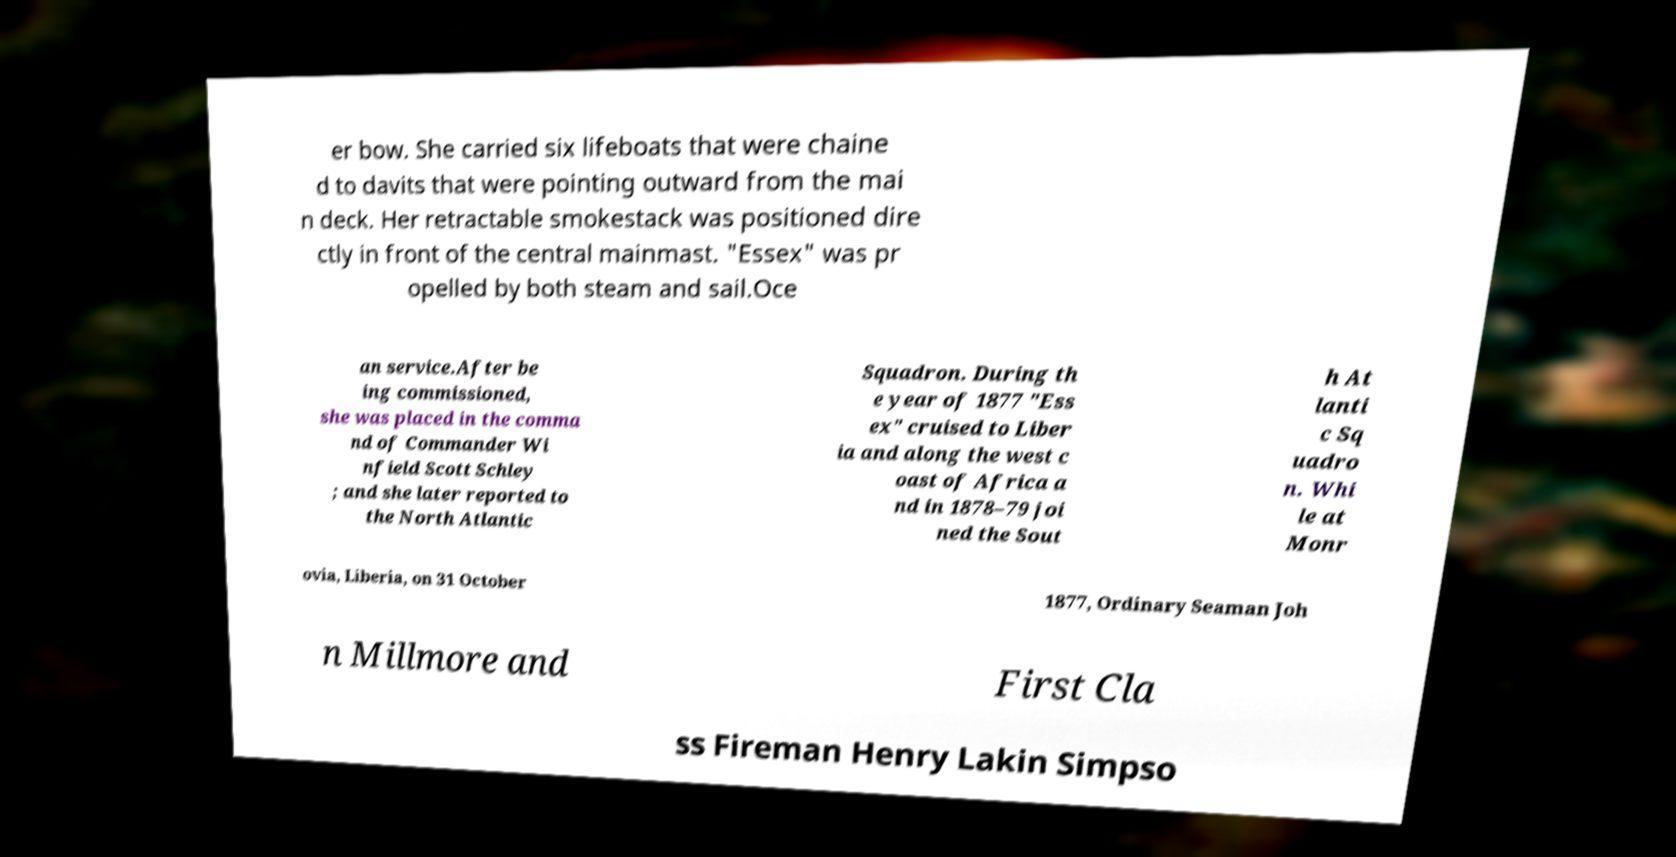Please read and relay the text visible in this image. What does it say? er bow. She carried six lifeboats that were chaine d to davits that were pointing outward from the mai n deck. Her retractable smokestack was positioned dire ctly in front of the central mainmast. "Essex" was pr opelled by both steam and sail.Oce an service.After be ing commissioned, she was placed in the comma nd of Commander Wi nfield Scott Schley ; and she later reported to the North Atlantic Squadron. During th e year of 1877 "Ess ex" cruised to Liber ia and along the west c oast of Africa a nd in 1878–79 joi ned the Sout h At lanti c Sq uadro n. Whi le at Monr ovia, Liberia, on 31 October 1877, Ordinary Seaman Joh n Millmore and First Cla ss Fireman Henry Lakin Simpso 